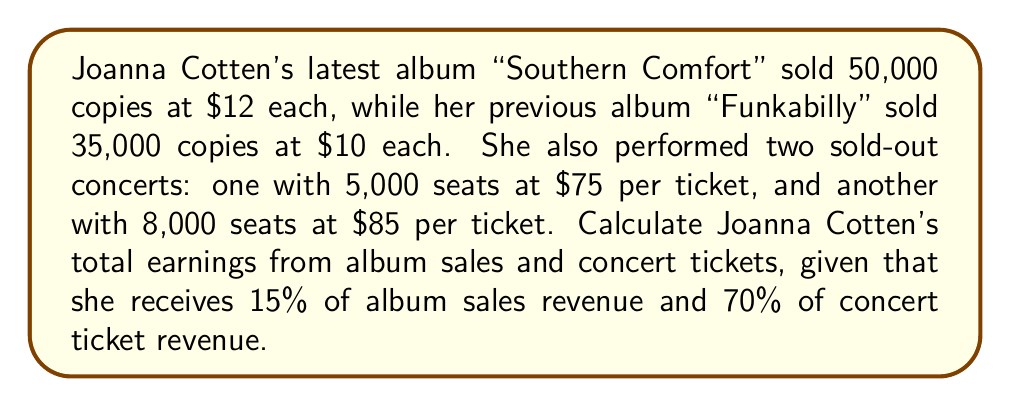Provide a solution to this math problem. Let's break this problem down into steps:

1. Calculate album sales revenue:
   "Southern Comfort": $50,000 \times \$12 = \$600,000$
   "Funkabilly": $35,000 \times \$10 = \$350,000$
   Total album sales revenue: $\$600,000 + \$350,000 = \$950,000$

2. Calculate Joanna's earnings from album sales:
   $\$950,000 \times 15\% = \$950,000 \times 0.15 = \$142,500$

3. Calculate concert ticket revenue:
   First concert: $5,000 \times \$75 = \$375,000$
   Second concert: $8,000 \times \$85 = \$680,000$
   Total concert ticket revenue: $\$375,000 + \$680,000 = \$1,055,000$

4. Calculate Joanna's earnings from concert tickets:
   $\$1,055,000 \times 70\% = \$1,055,000 \times 0.70 = \$738,500$

5. Sum up Joanna's total earnings:
   Album sales earnings + Concert ticket earnings
   $\$142,500 + \$738,500 = \$881,000$

Therefore, Joanna Cotten's total earnings from album sales and concert tickets are $\$881,000$.
Answer: $\$881,000$ 